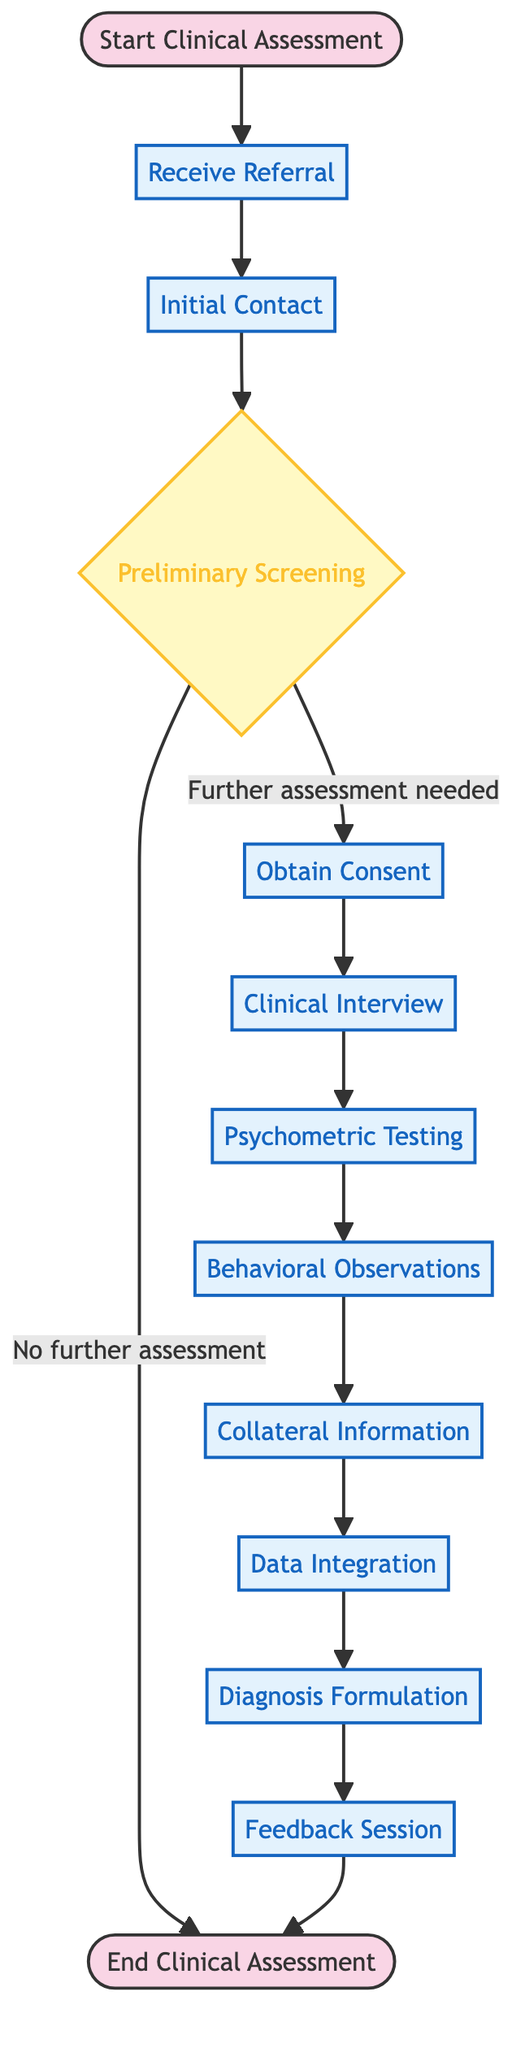What is the first activity in the clinical assessment? The diagram indicates that the first activity that follows "Start Clinical Assessment" is "Receive Referral."
Answer: Receive Referral How many activities are there in total? Counting the activities listed in the diagram, there are 11 distinct activities leading up to the end of the assessment.
Answer: 11 What is the last activity before the assessment ends? According to the diagram, the final activity before reaching "End Clinical Assessment" is "Feedback Session."
Answer: Feedback Session What decision is made after the Preliminary Screening? The diagram shows that the decision made after this activity is whether further assessment is needed or not, indicating two possible outcomes.
Answer: Further assessment needed / No further assessment Which activity requires obtaining consent? In the workflow, the activity "Obtain Consent" directly follows "Preliminary Screening," indicating that it is the only step where consent is specifically required.
Answer: Obtain Consent What position does the "Clinical Interview" hold in the sequence? The "Clinical Interview" comes after "Obtain Consent" and is the fifth step in the process, in a linear sequence of the activities.
Answer: Fifth step What sources can provide collateral information? The diagram notes gathering collateral information from sources such as family, teachers, or medical records, which means multiple types of individuals can contribute information.
Answer: Family, teachers, medical records How many steps are there between the "Initial Contact" and the "Feedback Session"? By tracing the flow from "Initial Contact" to "Feedback Session," there are a total of 9 steps connecting these two activities, including all intermediary activities.
Answer: 9 steps Is "Psychometric Testing" dependent on the "Clinical Interview"? Yes, the flow indicates that "Psychometric Testing" occurs after the "Clinical Interview," denoting a dependency in the order of activities during assessment.
Answer: Yes 